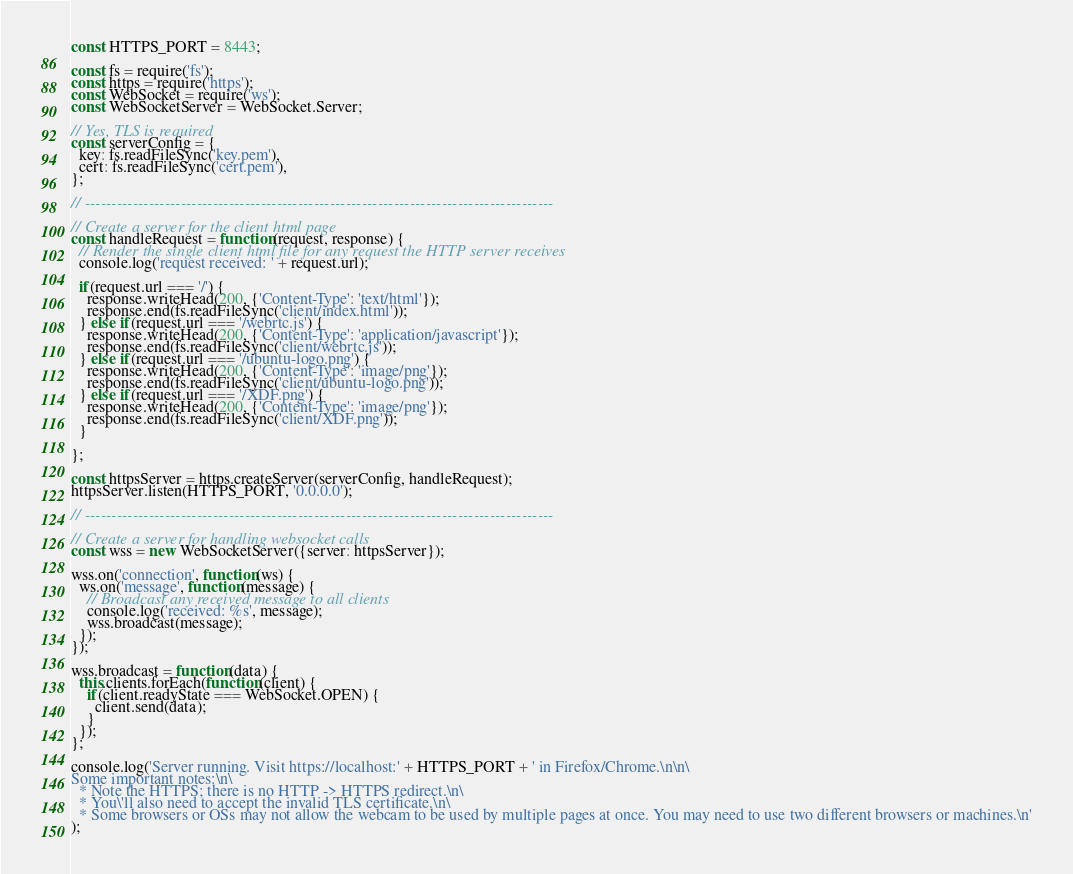<code> <loc_0><loc_0><loc_500><loc_500><_JavaScript_>const HTTPS_PORT = 8443;

const fs = require('fs');
const https = require('https');
const WebSocket = require('ws');
const WebSocketServer = WebSocket.Server;

// Yes, TLS is required
const serverConfig = {
  key: fs.readFileSync('key.pem'),
  cert: fs.readFileSync('cert.pem'),
};

// ----------------------------------------------------------------------------------------

// Create a server for the client html page
const handleRequest = function(request, response) {
  // Render the single client html file for any request the HTTP server receives
  console.log('request received: ' + request.url);

  if(request.url === '/') {
    response.writeHead(200, {'Content-Type': 'text/html'});
    response.end(fs.readFileSync('client/index.html'));
  } else if(request.url === '/webrtc.js') {
    response.writeHead(200, {'Content-Type': 'application/javascript'});
    response.end(fs.readFileSync('client/webrtc.js'));
  } else if(request.url === '/ubuntu-logo.png') {
    response.writeHead(200, {'Content-Type': 'image/png'});
    response.end(fs.readFileSync('client/ubuntu-logo.png'));
  } else if(request.url === '/XDF.png') {
    response.writeHead(200, {'Content-Type': 'image/png'});
    response.end(fs.readFileSync('client/XDF.png'));
  }
  
};

const httpsServer = https.createServer(serverConfig, handleRequest);
httpsServer.listen(HTTPS_PORT, '0.0.0.0');

// ----------------------------------------------------------------------------------------

// Create a server for handling websocket calls
const wss = new WebSocketServer({server: httpsServer});

wss.on('connection', function(ws) {
  ws.on('message', function(message) {
    // Broadcast any received message to all clients
    console.log('received: %s', message);
    wss.broadcast(message);
  });
});

wss.broadcast = function(data) {
  this.clients.forEach(function(client) {
    if(client.readyState === WebSocket.OPEN) {
      client.send(data);
    }
  });
};

console.log('Server running. Visit https://localhost:' + HTTPS_PORT + ' in Firefox/Chrome.\n\n\
Some important notes:\n\
  * Note the HTTPS; there is no HTTP -> HTTPS redirect.\n\
  * You\'ll also need to accept the invalid TLS certificate.\n\
  * Some browsers or OSs may not allow the webcam to be used by multiple pages at once. You may need to use two different browsers or machines.\n'
);
</code> 